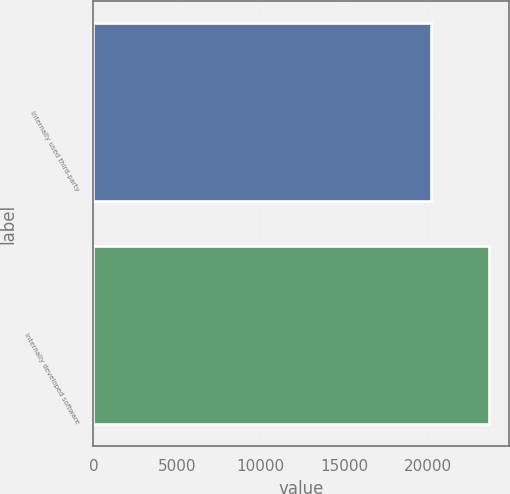<chart> <loc_0><loc_0><loc_500><loc_500><bar_chart><fcel>Internally used third-party<fcel>Internally developed software<nl><fcel>20202<fcel>23665<nl></chart> 